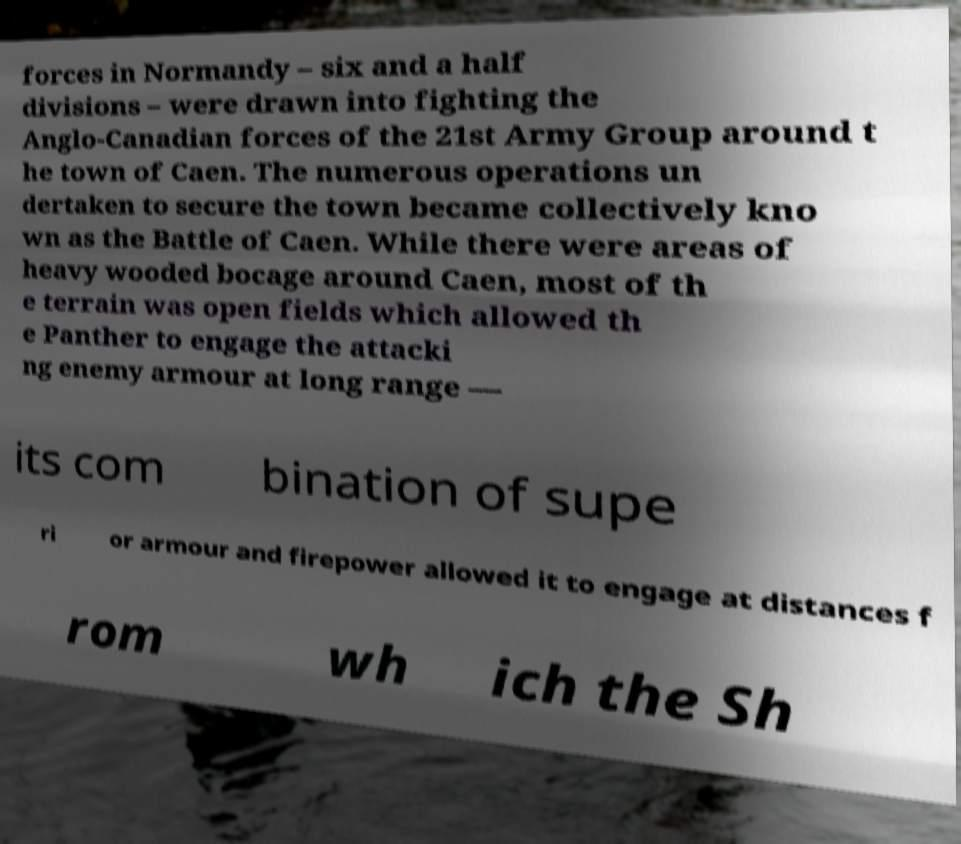Please read and relay the text visible in this image. What does it say? forces in Normandy – six and a half divisions – were drawn into fighting the Anglo-Canadian forces of the 21st Army Group around t he town of Caen. The numerous operations un dertaken to secure the town became collectively kno wn as the Battle of Caen. While there were areas of heavy wooded bocage around Caen, most of th e terrain was open fields which allowed th e Panther to engage the attacki ng enemy armour at long range — its com bination of supe ri or armour and firepower allowed it to engage at distances f rom wh ich the Sh 